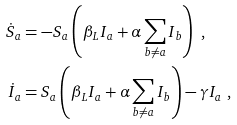Convert formula to latex. <formula><loc_0><loc_0><loc_500><loc_500>\dot { S } _ { a } & = - S _ { a } \left ( \beta _ { L } I _ { a } + \alpha \sum _ { b \neq a } I _ { b } \right ) \text { ,} \\ \dot { I } _ { a } & = S _ { a } \left ( \beta _ { L } I _ { a } + \alpha \sum _ { b \neq a } I _ { b } \right ) - \gamma I _ { a } \text { ,}</formula> 